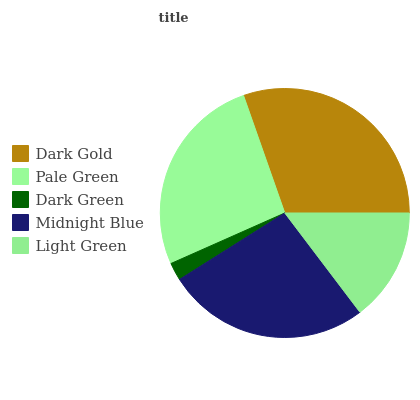Is Dark Green the minimum?
Answer yes or no. Yes. Is Dark Gold the maximum?
Answer yes or no. Yes. Is Pale Green the minimum?
Answer yes or no. No. Is Pale Green the maximum?
Answer yes or no. No. Is Dark Gold greater than Pale Green?
Answer yes or no. Yes. Is Pale Green less than Dark Gold?
Answer yes or no. Yes. Is Pale Green greater than Dark Gold?
Answer yes or no. No. Is Dark Gold less than Pale Green?
Answer yes or no. No. Is Pale Green the high median?
Answer yes or no. Yes. Is Pale Green the low median?
Answer yes or no. Yes. Is Dark Gold the high median?
Answer yes or no. No. Is Midnight Blue the low median?
Answer yes or no. No. 